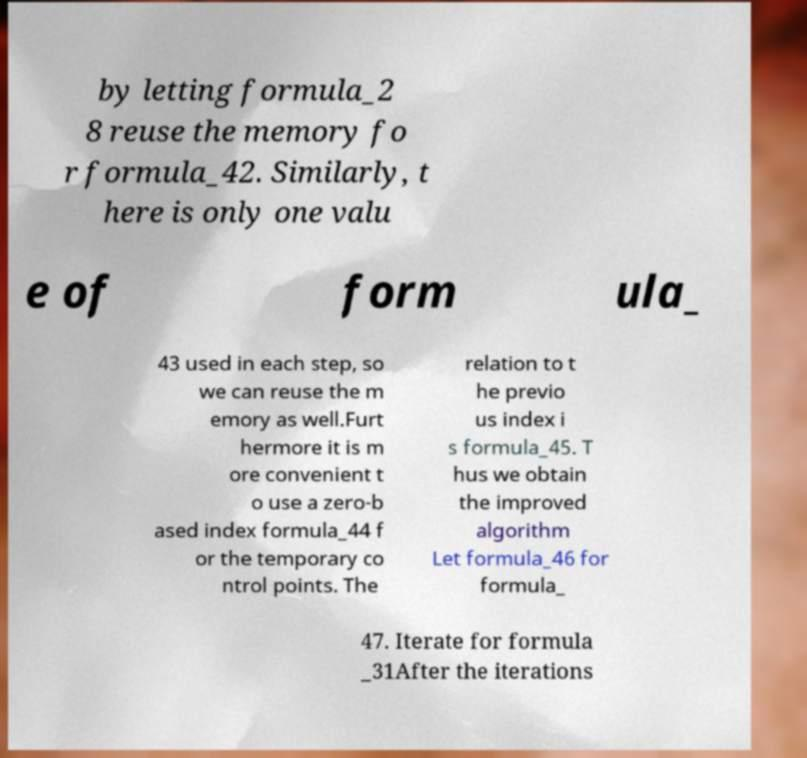Please read and relay the text visible in this image. What does it say? by letting formula_2 8 reuse the memory fo r formula_42. Similarly, t here is only one valu e of form ula_ 43 used in each step, so we can reuse the m emory as well.Furt hermore it is m ore convenient t o use a zero-b ased index formula_44 f or the temporary co ntrol points. The relation to t he previo us index i s formula_45. T hus we obtain the improved algorithm Let formula_46 for formula_ 47. Iterate for formula _31After the iterations 